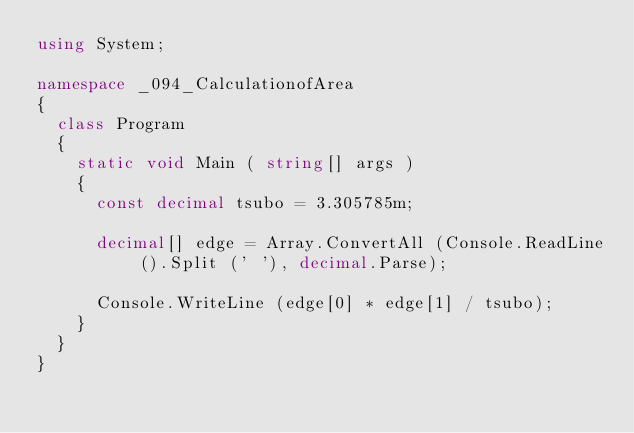Convert code to text. <code><loc_0><loc_0><loc_500><loc_500><_C#_>using System;

namespace _094_CalculationofArea
{
	class Program
	{
		static void Main ( string[] args )
		{
			const decimal tsubo = 3.305785m;

			decimal[] edge = Array.ConvertAll (Console.ReadLine ().Split (' '), decimal.Parse);

			Console.WriteLine (edge[0] * edge[1] / tsubo);
		}
	}
}</code> 